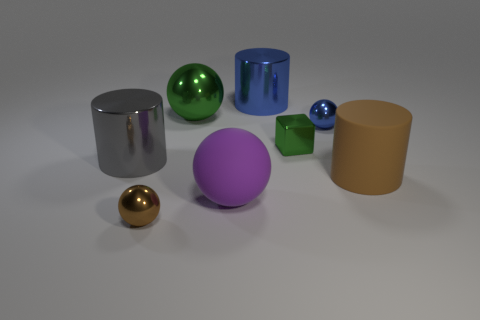Subtract all blue cylinders. How many cylinders are left? 2 Add 2 small purple matte blocks. How many objects exist? 10 Subtract 3 cylinders. How many cylinders are left? 0 Subtract all brown balls. How many balls are left? 3 Subtract all cubes. How many objects are left? 7 Subtract all big cylinders. Subtract all green objects. How many objects are left? 3 Add 7 matte spheres. How many matte spheres are left? 8 Add 3 tiny brown metal things. How many tiny brown metal things exist? 4 Subtract 0 cyan cubes. How many objects are left? 8 Subtract all cyan cylinders. Subtract all brown spheres. How many cylinders are left? 3 